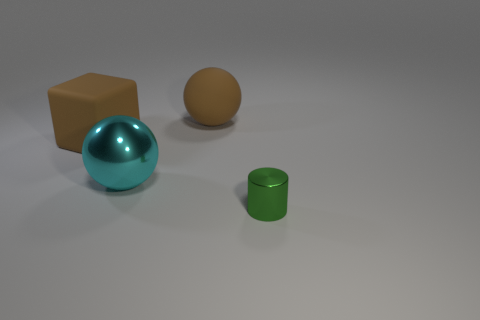Are there any other things that are the same shape as the small green object?
Make the answer very short. No. How many metal things are either small blue cylinders or big blocks?
Your answer should be compact. 0. There is a metal thing behind the green cylinder; what color is it?
Your answer should be compact. Cyan. The rubber object that is the same size as the brown cube is what shape?
Make the answer very short. Sphere. Does the large rubber block have the same color as the matte thing behind the cube?
Offer a very short reply. Yes. What number of things are things on the right side of the big brown sphere or metal cylinders in front of the brown sphere?
Make the answer very short. 1. What material is the brown object that is the same size as the rubber ball?
Your answer should be compact. Rubber. How many other objects are there of the same material as the tiny green thing?
Provide a short and direct response. 1. Is the shape of the large brown rubber thing that is on the right side of the large cyan metallic object the same as the green metal object to the right of the large block?
Provide a short and direct response. No. What is the color of the large rubber object behind the matte thing left of the metallic object that is behind the tiny metallic cylinder?
Offer a very short reply. Brown. 